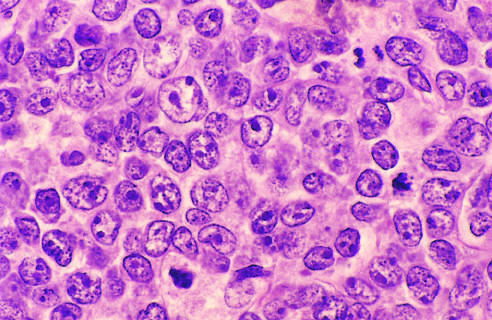do the tumor cells have large nuclei with open chromatin and prominent nucleoli?
Answer the question using a single word or phrase. Yes 